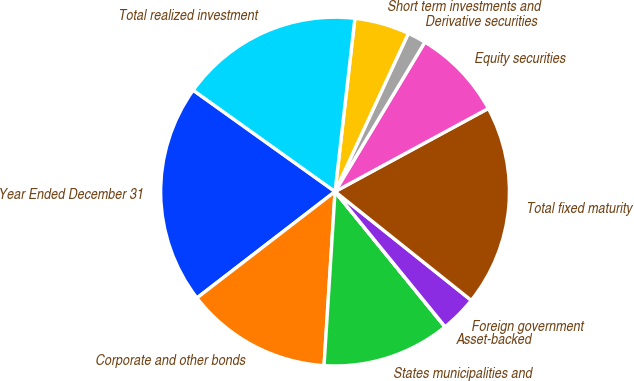Convert chart. <chart><loc_0><loc_0><loc_500><loc_500><pie_chart><fcel>Year Ended December 31<fcel>Corporate and other bonds<fcel>States municipalities and<fcel>Asset-backed<fcel>Foreign government<fcel>Total fixed maturity<fcel>Equity securities<fcel>Derivative securities<fcel>Short term investments and<fcel>Total realized investment<nl><fcel>20.32%<fcel>13.55%<fcel>11.86%<fcel>0.02%<fcel>3.4%<fcel>18.63%<fcel>8.48%<fcel>1.71%<fcel>5.09%<fcel>16.94%<nl></chart> 